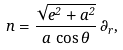<formula> <loc_0><loc_0><loc_500><loc_500>n = \frac { \sqrt { e ^ { 2 } + a ^ { 2 } } } { a \, \cos \theta } \, \partial _ { r } ,</formula> 